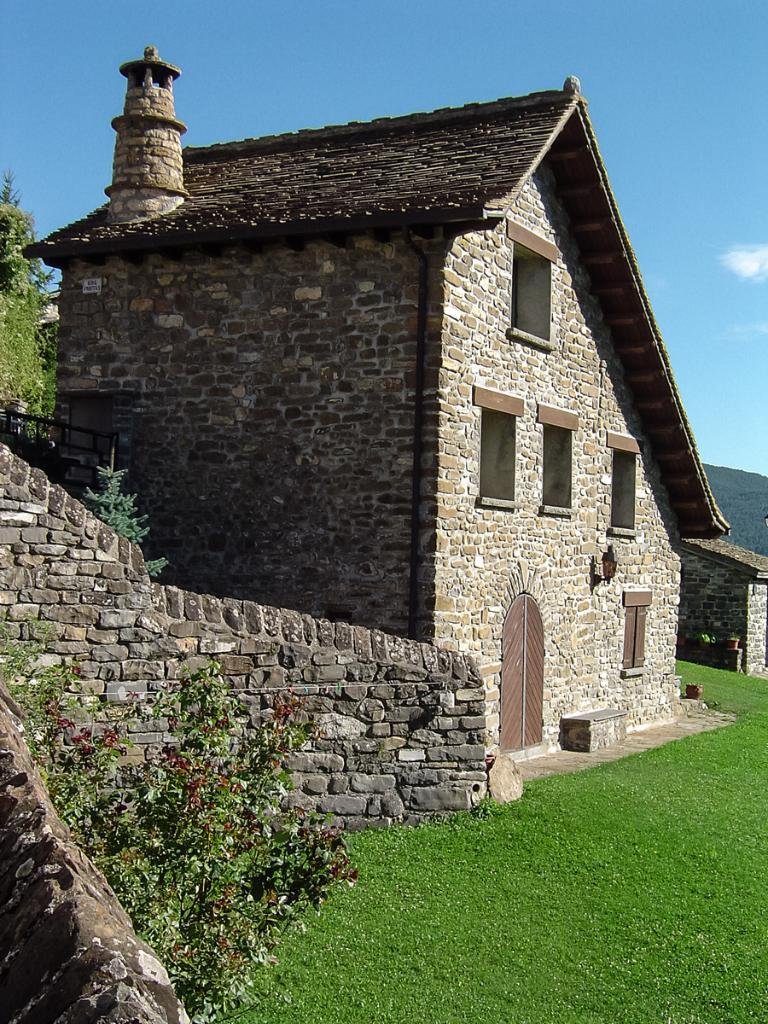What type of structure is visible in the image? There is a house in the image. What is on the ground around the house? There is grass on the ground in the image. What type of barrier is present in the image? There is a stone wall in the image. What type of vegetation can be seen in the image? There are plants and trees in the image. What color is the sky in the image? The sky is blue and visible at the top of the image. Can you see any pies on the stone wall in the image? There are no pies present in the image; it features a house, grass, stone wall, plants, trees, and a blue sky. Is there a crown visible on the roof of the house in the image? There is no crown present on the roof of the house in the image. 